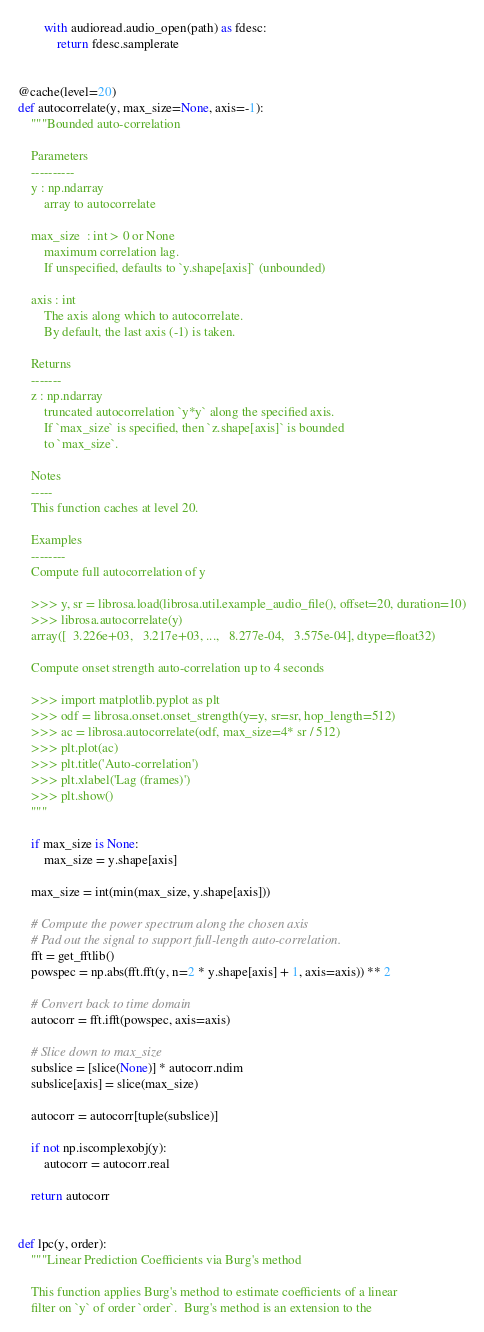<code> <loc_0><loc_0><loc_500><loc_500><_Python_>        with audioread.audio_open(path) as fdesc:
            return fdesc.samplerate


@cache(level=20)
def autocorrelate(y, max_size=None, axis=-1):
    """Bounded auto-correlation

    Parameters
    ----------
    y : np.ndarray
        array to autocorrelate

    max_size  : int > 0 or None
        maximum correlation lag.
        If unspecified, defaults to `y.shape[axis]` (unbounded)

    axis : int
        The axis along which to autocorrelate.
        By default, the last axis (-1) is taken.

    Returns
    -------
    z : np.ndarray
        truncated autocorrelation `y*y` along the specified axis.
        If `max_size` is specified, then `z.shape[axis]` is bounded
        to `max_size`.

    Notes
    -----
    This function caches at level 20.

    Examples
    --------
    Compute full autocorrelation of y

    >>> y, sr = librosa.load(librosa.util.example_audio_file(), offset=20, duration=10)
    >>> librosa.autocorrelate(y)
    array([  3.226e+03,   3.217e+03, ...,   8.277e-04,   3.575e-04], dtype=float32)

    Compute onset strength auto-correlation up to 4 seconds

    >>> import matplotlib.pyplot as plt
    >>> odf = librosa.onset.onset_strength(y=y, sr=sr, hop_length=512)
    >>> ac = librosa.autocorrelate(odf, max_size=4* sr / 512)
    >>> plt.plot(ac)
    >>> plt.title('Auto-correlation')
    >>> plt.xlabel('Lag (frames)')
    >>> plt.show()
    """

    if max_size is None:
        max_size = y.shape[axis]

    max_size = int(min(max_size, y.shape[axis]))

    # Compute the power spectrum along the chosen axis
    # Pad out the signal to support full-length auto-correlation.
    fft = get_fftlib()
    powspec = np.abs(fft.fft(y, n=2 * y.shape[axis] + 1, axis=axis)) ** 2

    # Convert back to time domain
    autocorr = fft.ifft(powspec, axis=axis)

    # Slice down to max_size
    subslice = [slice(None)] * autocorr.ndim
    subslice[axis] = slice(max_size)

    autocorr = autocorr[tuple(subslice)]

    if not np.iscomplexobj(y):
        autocorr = autocorr.real

    return autocorr


def lpc(y, order):
    """Linear Prediction Coefficients via Burg's method

    This function applies Burg's method to estimate coefficients of a linear
    filter on `y` of order `order`.  Burg's method is an extension to the</code> 